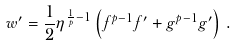Convert formula to latex. <formula><loc_0><loc_0><loc_500><loc_500>w ^ { \prime } = \frac { 1 } { 2 } \eta ^ { \frac { 1 } { p } - 1 } \left ( f ^ { p - 1 } f ^ { \prime } + g ^ { p - 1 } g ^ { \prime } \right ) \, .</formula> 